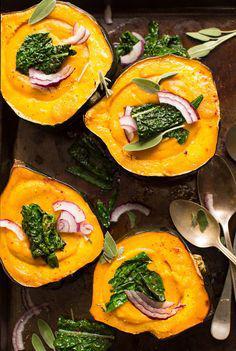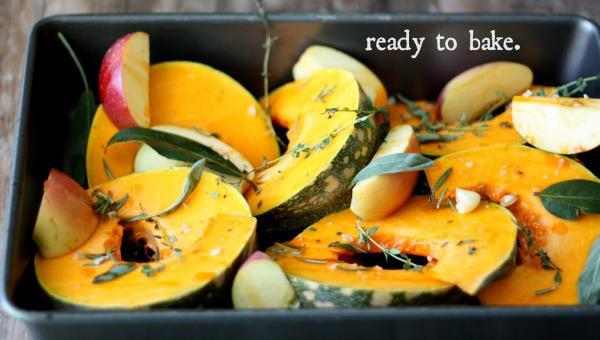The first image is the image on the left, the second image is the image on the right. For the images displayed, is the sentence "Some of the squash in the image on the left sit on a black tray." factually correct? Answer yes or no. No. The first image is the image on the left, the second image is the image on the right. Analyze the images presented: Is the assertion "The left image contains squash cut in half." valid? Answer yes or no. Yes. 